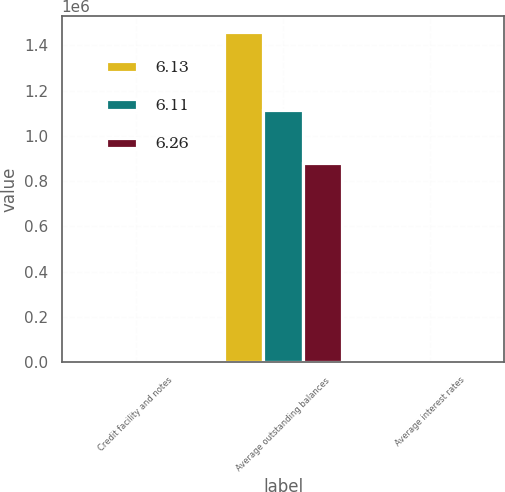Convert chart to OTSL. <chart><loc_0><loc_0><loc_500><loc_500><stacked_bar_chart><ecel><fcel>Credit facility and notes<fcel>Average outstanding balances<fcel>Average interest rates<nl><fcel>6.13<fcel>2008<fcel>1.45722e+06<fcel>6.26<nl><fcel>6.11<fcel>2007<fcel>1.11191e+06<fcel>6.11<nl><fcel>6.26<fcel>2006<fcel>881669<fcel>6.13<nl></chart> 